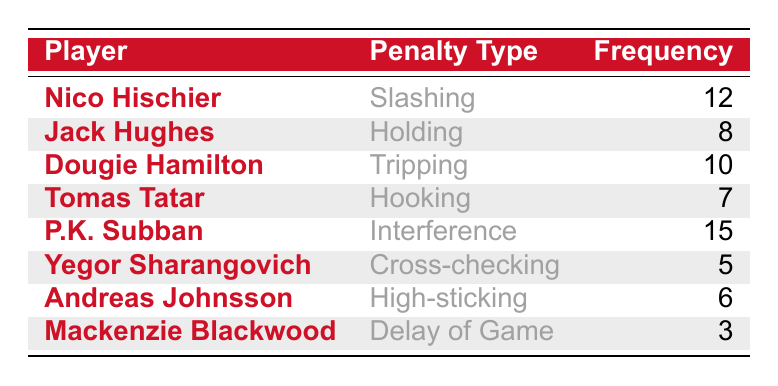What is the highest frequency of penalties taken by a player? Look at the "Frequency" column and identify the maximum value. The highest number listed is 15, which belongs to P.K. Subban.
Answer: 15 Which player has committed the fewest penalties? Review the "Frequency" column to find the lowest value. The minimum frequency is 3, attributed to Mackenzie Blackwood.
Answer: 3 How many penalties did Dougie Hamilton take? Locate Dougie Hamilton's row in the table and read the corresponding frequency, which is 10.
Answer: 10 Is Tomas Tatar's penalty type more frequent than Yegor Sharangovich's? Compare the frequencies of these two players. Tomas Tatar has 7 penalties (Hooking), while Yegor Sharangovich has 5 (Cross-checking). Since 7 is greater than 5, Tatar’s penalties are more frequent.
Answer: Yes What is the total number of penalties taken by all players combined? Sum the frequencies of all players. The individual penalties are: 12 (Nico) + 8 (Jack) + 10 (Dougie) + 7 (Tomas) + 15 (P.K.) + 5 (Yegor) + 6 (Andreas) + 3 (Mackenzie) = 66. Therefore, the total is 66.
Answer: 66 Which penalty type is taken the most by the players? Identify the frequency of each penalty type and determine the one with the highest count. P.K. Subban's Interference has the highest count at 15, making it the most frequent penalty type.
Answer: Interference How many players took penalties that have a frequency of 8 or more? Count the players with a frequency of 8 or more. The players are Nico Hischier (12), Dougie Hamilton (10), P.K. Subban (15), and Jack Hughes (8), totaling four players.
Answer: 4 What is the average frequency of penalties taken by the team? Sum all penalty frequencies (66) and divide by the number of players (8). Therefore, the average frequency is 66/8 = 8.25.
Answer: 8.25 Did any player take penalties for both "Interference" and "Slashing"? Check the table to see if any player is associated with both penalty types. P.K. Subban is specifically associated with Interference and Nico Hischier with Slashing; therefore, no player took both.
Answer: No 